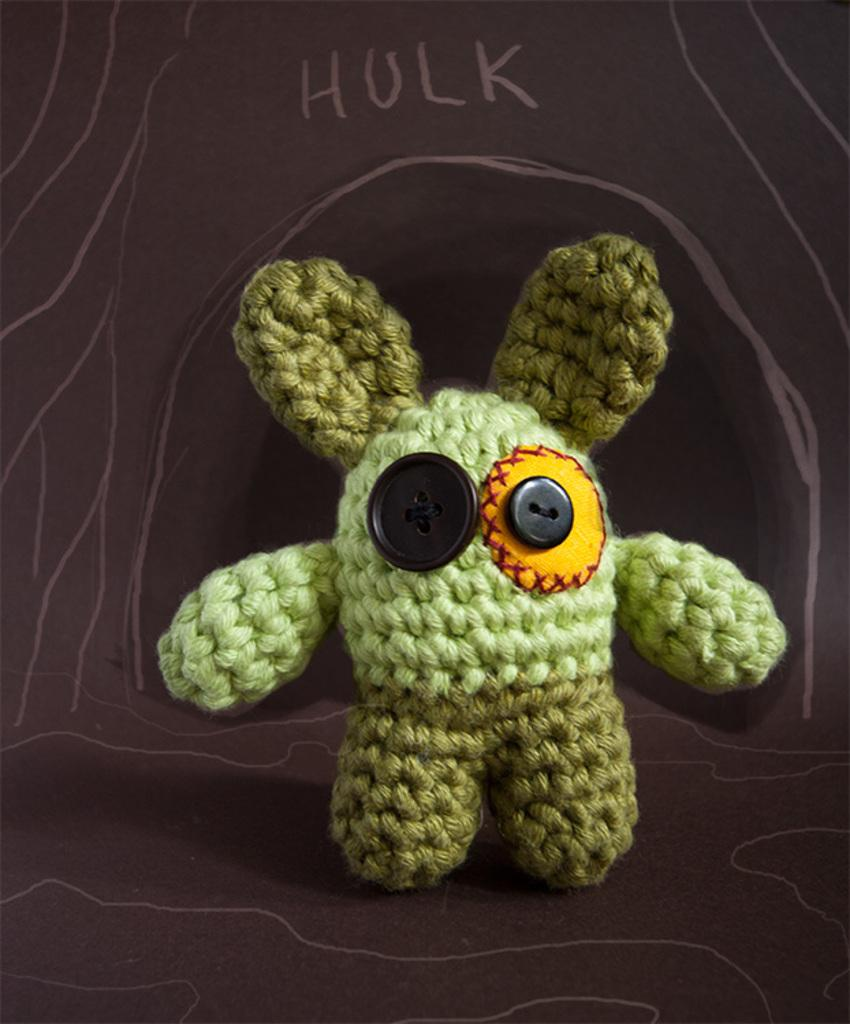What is the main subject of the image? The main subject of the image is a structure made up of woolen threads and buttons. Can you describe the structure in more detail? Unfortunately, the provided facts do not offer more detail about the structure. What is mentioned in the background of the image? The word "hulk" is mentioned in the background of the image. What type of play is being performed on the roof in the image? There is no play or roof present in the image. The image features a structure made up of woolen threads and buttons, and the word "hulk" mentioned in the background. 